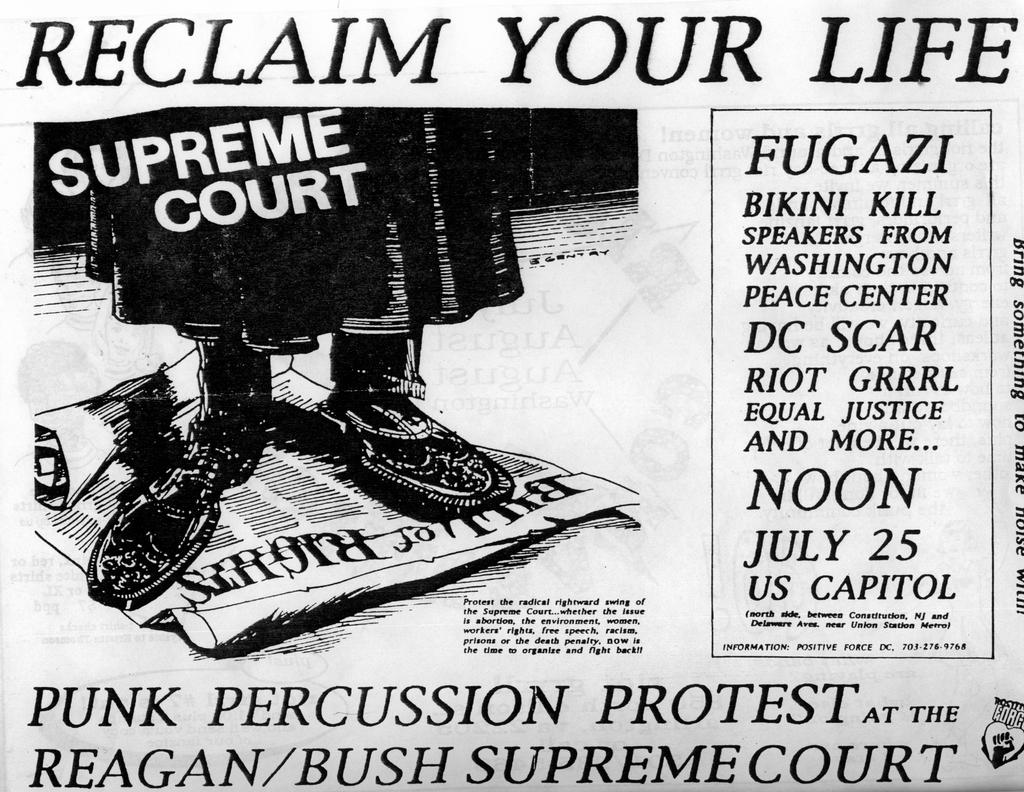What is present on the paper in the image? There is writing on the paper. Can you describe any other elements in the image besides the paper? Yes, there are legs of a person visible in the image. What type of nose can be seen on the ghost in the image? There is no ghost present in the image, and therefore no nose can be observed. 